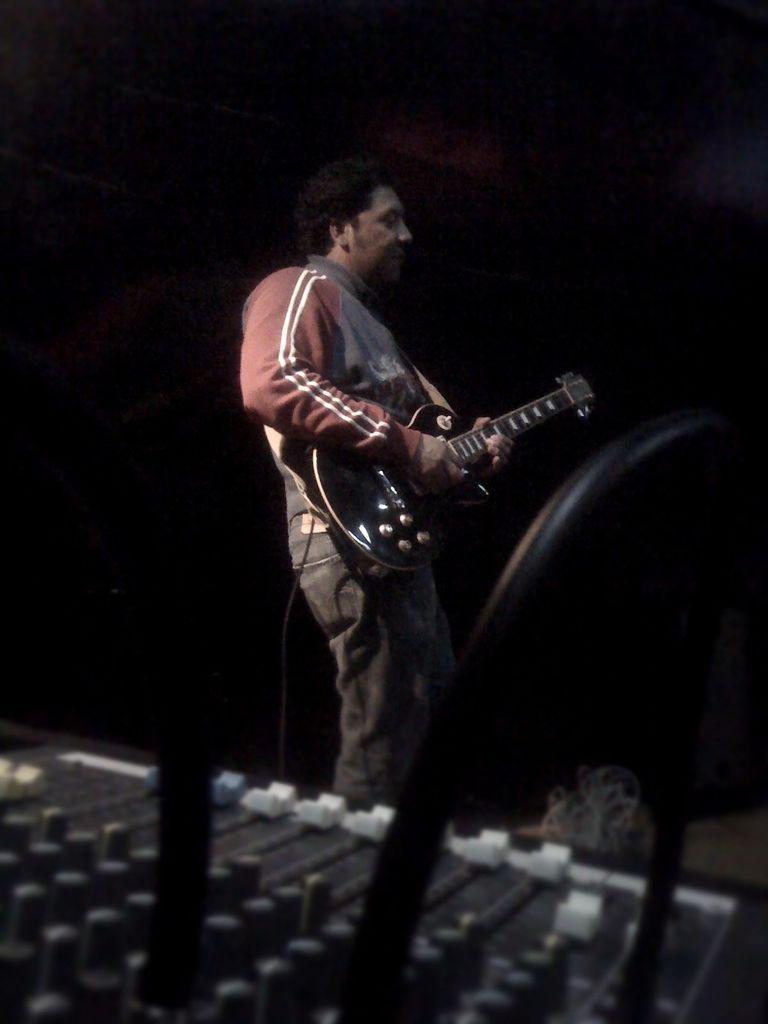How would you summarize this image in a sentence or two? In this image we can see a person standing in the center. He is holding a guitar in his hand. 